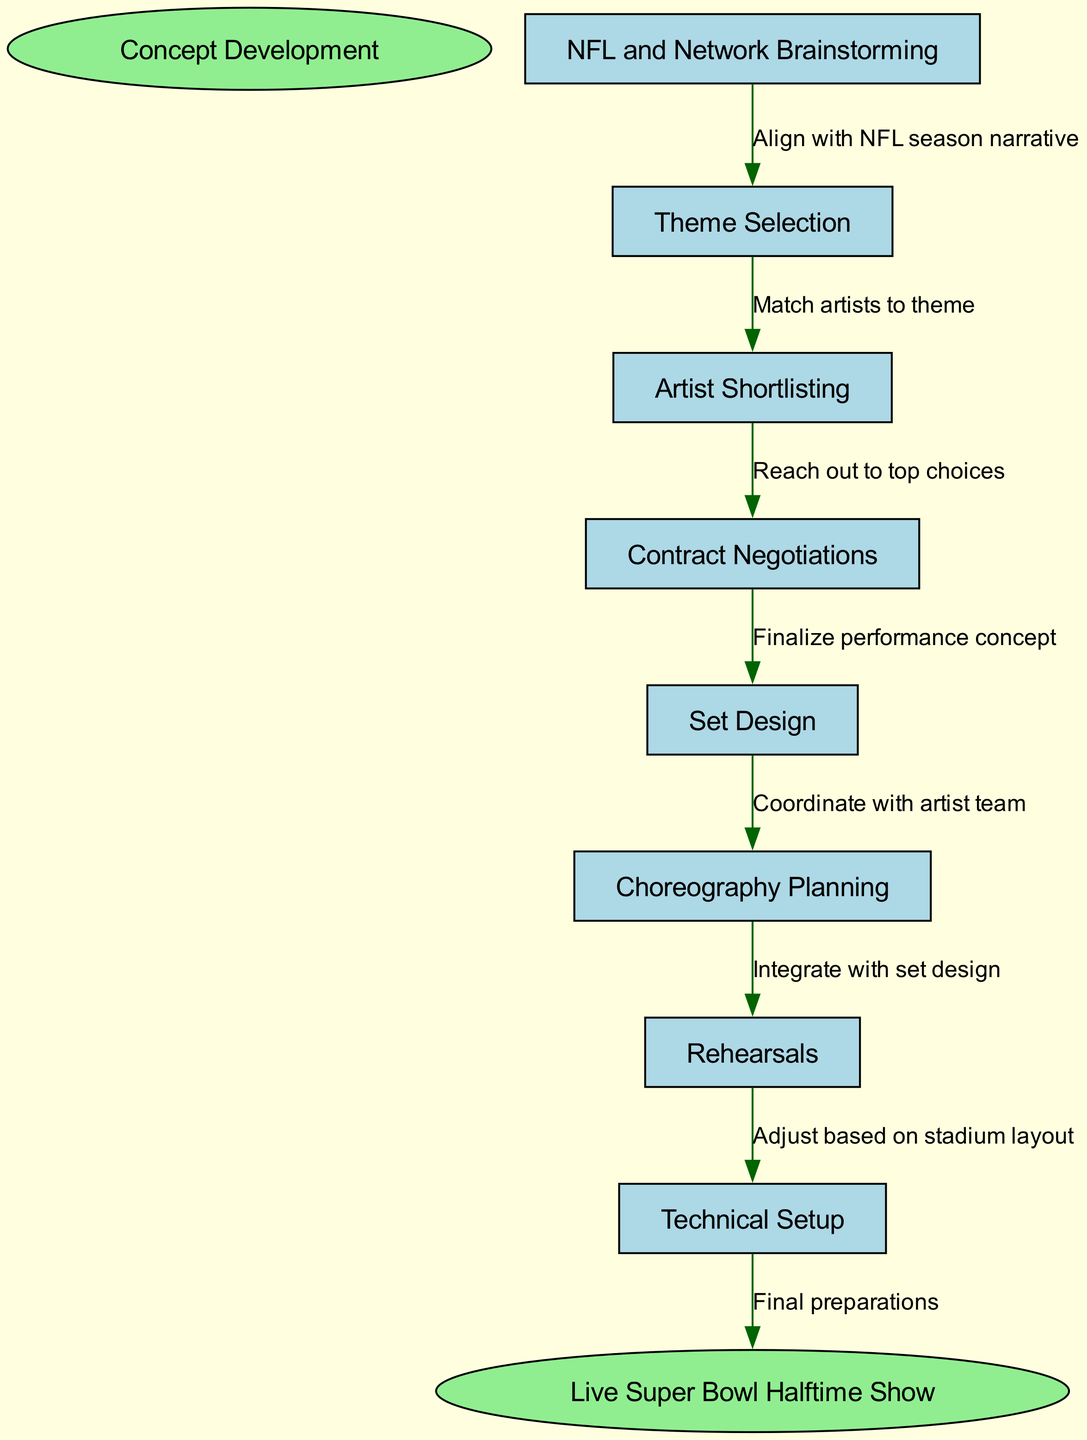What is the first step in the Super Bowl halftime show planning? The diagram indicates that the first step in the Super Bowl halftime show planning is "Concept Development," represented at the start of the flow.
Answer: Concept Development How many nodes are there in total in the diagram? Counting the nodes listed in the diagram, we see there are eight distinct nodes plus the start and end nodes, which totals ten nodes.
Answer: 10 What is the last step before the live Super Bowl halftime show? The diagram shows that the last step before the live performance is "Technical Setup," which is the final action before the event occurs.
Answer: Technical Setup Which node represents the planning of choreography? Referring to the diagram, "Choreography Planning" is explicitly labeled as node six in the flow.
Answer: Choreography Planning What connects "Set Design" to "Choreography Planning"? The edge between "Set Design" and "Choreography Planning" is defined by the text "Coordinate with artist team," indicating how one process flows into the next.
Answer: Coordinate with artist team What is the relationship between "NFL and Network Brainstorming" and "Theme Selection"? The relationship is described by the edge that states "Align with NFL season narrative," signifying that the brainstorming influences the selection of themes.
Answer: Align with NFL season narrative How many edges are depicted in the diagram? By analyzing the transitions shown between the nodes in the diagram, we can see there are seven directed edges connecting various steps in the process.
Answer: 7 Which two nodes are directly connected to "Artist Shortlisting"? According to the diagram, "Artist Shortlisting" connects directly to "Theme Selection" (preceding it) and "Contract Negotiations" (following it).
Answer: Theme Selection, Contract Negotiations What is the overall goal of this flow chart? The final outcome indicated in the diagram is the "Live Super Bowl Halftime Show," which is the culmination of all the prior planning stages.
Answer: Live Super Bowl Halftime Show 